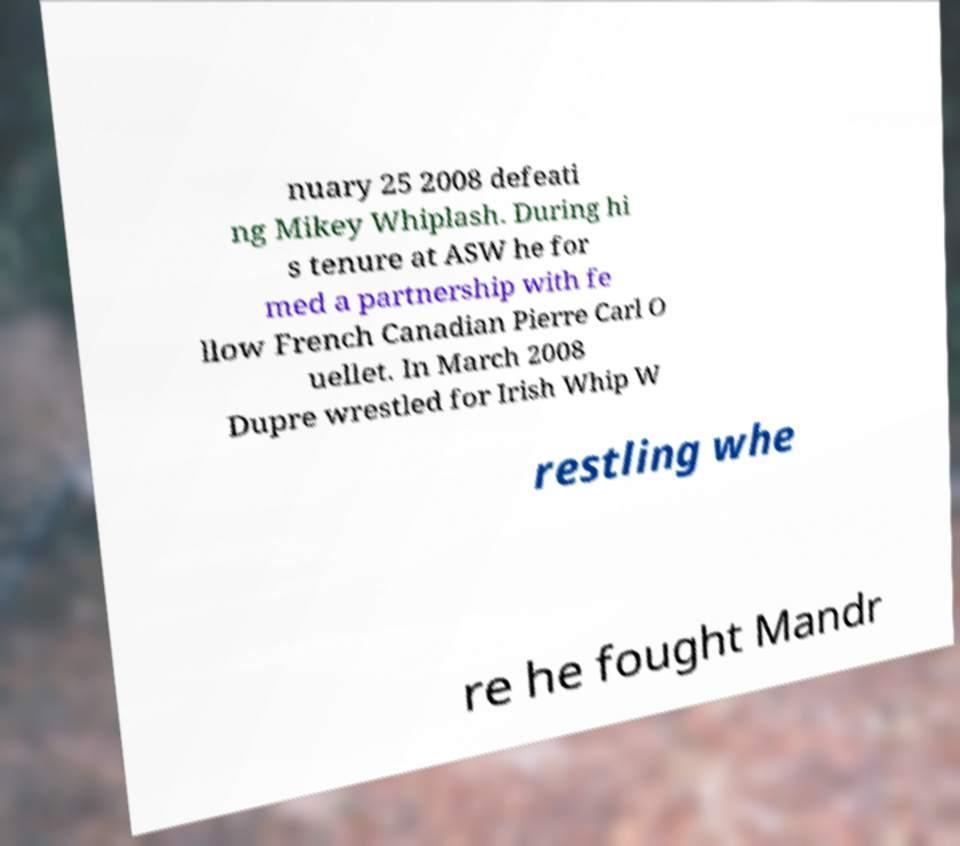Can you read and provide the text displayed in the image?This photo seems to have some interesting text. Can you extract and type it out for me? nuary 25 2008 defeati ng Mikey Whiplash. During hi s tenure at ASW he for med a partnership with fe llow French Canadian Pierre Carl O uellet. In March 2008 Dupre wrestled for Irish Whip W restling whe re he fought Mandr 